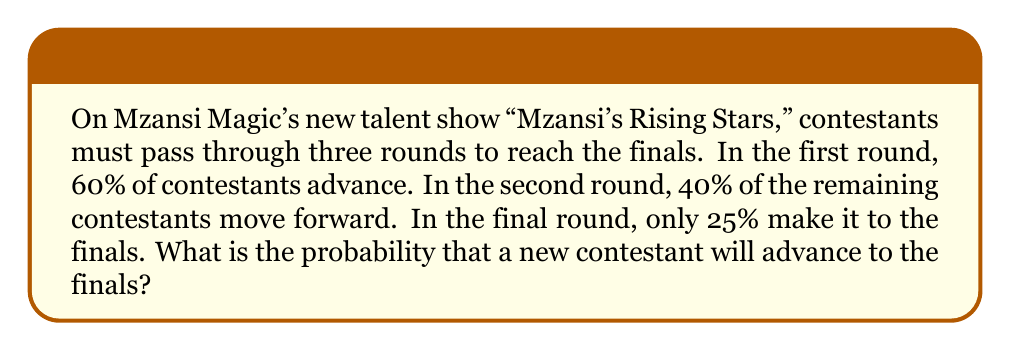Give your solution to this math problem. Let's approach this step-by-step:

1) We need to calculate the probability of a contestant passing all three rounds.

2) For each round, we'll multiply the probability of advancing:

   $P(\text{advancing to finals}) = P(\text{round 1}) \times P(\text{round 2}) \times P(\text{round 3})$

3) Given probabilities:
   - Round 1: 60% = 0.60
   - Round 2: 40% = 0.40
   - Round 3: 25% = 0.25

4) Let's multiply these probabilities:

   $P(\text{advancing to finals}) = 0.60 \times 0.40 \times 0.25$

5) Calculating:
   
   $P(\text{advancing to finals}) = 0.06$

6) To convert to a percentage:

   $0.06 \times 100\% = 6\%$

Thus, a new contestant has a 6% chance of advancing to the finals.
Answer: The probability that a new contestant will advance to the finals is 0.06 or 6%. 